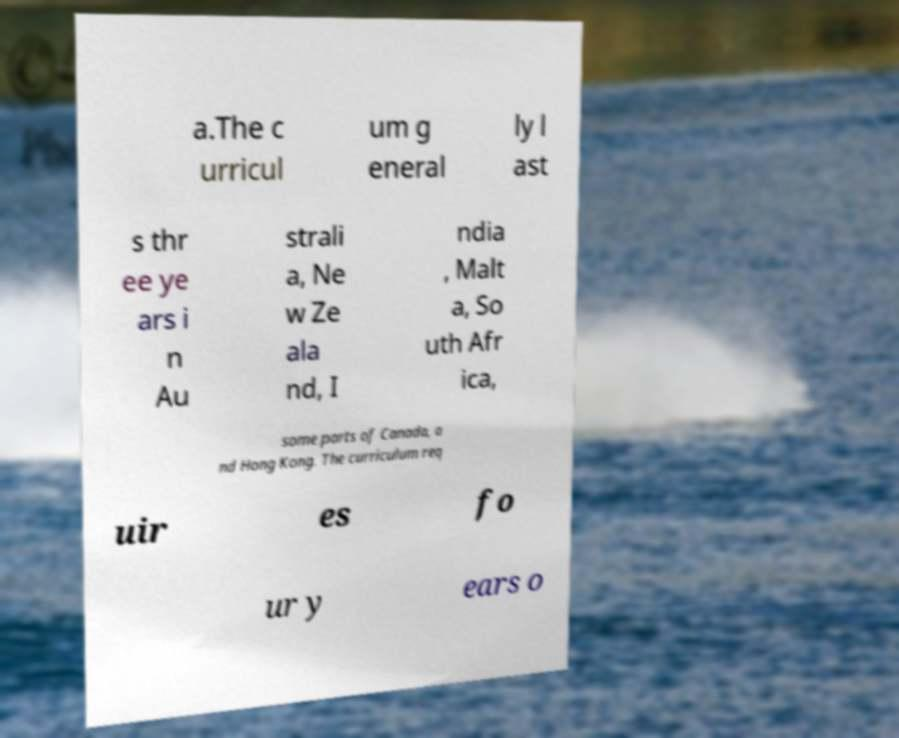Could you extract and type out the text from this image? a.The c urricul um g eneral ly l ast s thr ee ye ars i n Au strali a, Ne w Ze ala nd, I ndia , Malt a, So uth Afr ica, some parts of Canada, a nd Hong Kong. The curriculum req uir es fo ur y ears o 